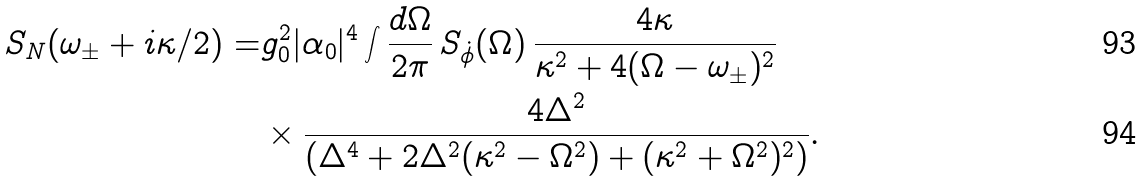<formula> <loc_0><loc_0><loc_500><loc_500>S _ { N } ( \omega _ { \pm } + i \kappa / 2 ) = & g _ { 0 } ^ { 2 } | \alpha _ { 0 } | ^ { 4 } \int \frac { d \Omega } { 2 \pi } \, S _ { \dot { \phi } } ( \Omega ) \, \frac { 4 \kappa } { \kappa ^ { 2 } + 4 ( \Omega - \omega _ { \pm } ) ^ { 2 } } \\ & \times \frac { 4 \Delta ^ { 2 } } { ( \Delta ^ { 4 } + 2 \Delta ^ { 2 } ( \kappa ^ { 2 } - \Omega ^ { 2 } ) + ( \kappa ^ { 2 } + \Omega ^ { 2 } ) ^ { 2 } ) } .</formula> 